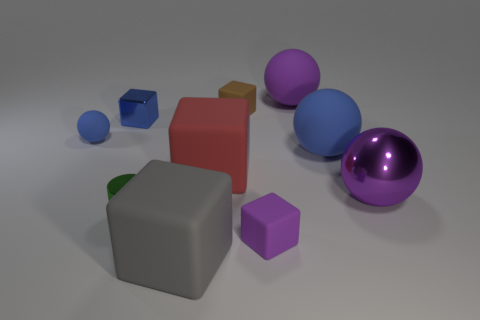There is a small rubber object that is the same shape as the large purple rubber thing; what is its color?
Your answer should be compact. Blue. There is a rubber ball that is to the right of the tiny metal cylinder and in front of the tiny blue metal object; how big is it?
Keep it short and to the point. Large. There is a blue rubber sphere that is on the left side of the tiny rubber block behind the blue metallic object; what number of brown objects are in front of it?
Ensure brevity in your answer.  0. How many large objects are either yellow metal objects or red rubber objects?
Give a very brief answer. 1. Is the block that is to the left of the big gray block made of the same material as the tiny green object?
Provide a succinct answer. Yes. What is the material of the purple sphere that is in front of the big matte cube that is right of the large block in front of the green shiny cylinder?
Your answer should be compact. Metal. Is there any other thing that is the same size as the green thing?
Your response must be concise. Yes. What number of metal objects are either green things or small blue objects?
Your answer should be very brief. 2. Are any gray things visible?
Provide a short and direct response. Yes. What color is the large rubber object behind the tiny metallic thing behind the tiny blue rubber thing?
Your answer should be compact. Purple. 